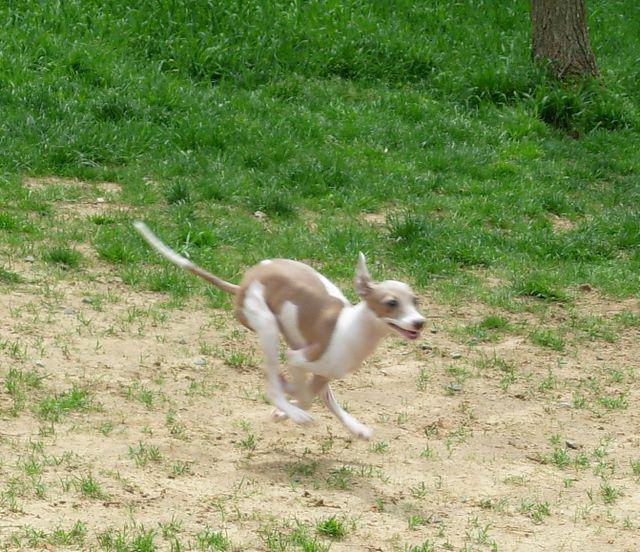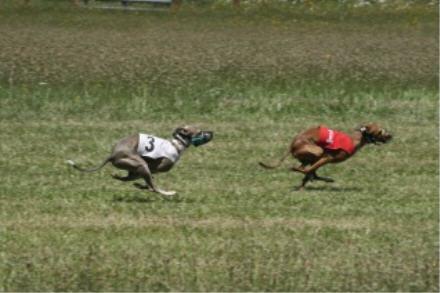The first image is the image on the left, the second image is the image on the right. Analyze the images presented: Is the assertion "An image shows a single dog bounding across a field, with its head partially forward." valid? Answer yes or no. Yes. The first image is the image on the left, the second image is the image on the right. For the images displayed, is the sentence "An image contains exactly two dogs." factually correct? Answer yes or no. Yes. 